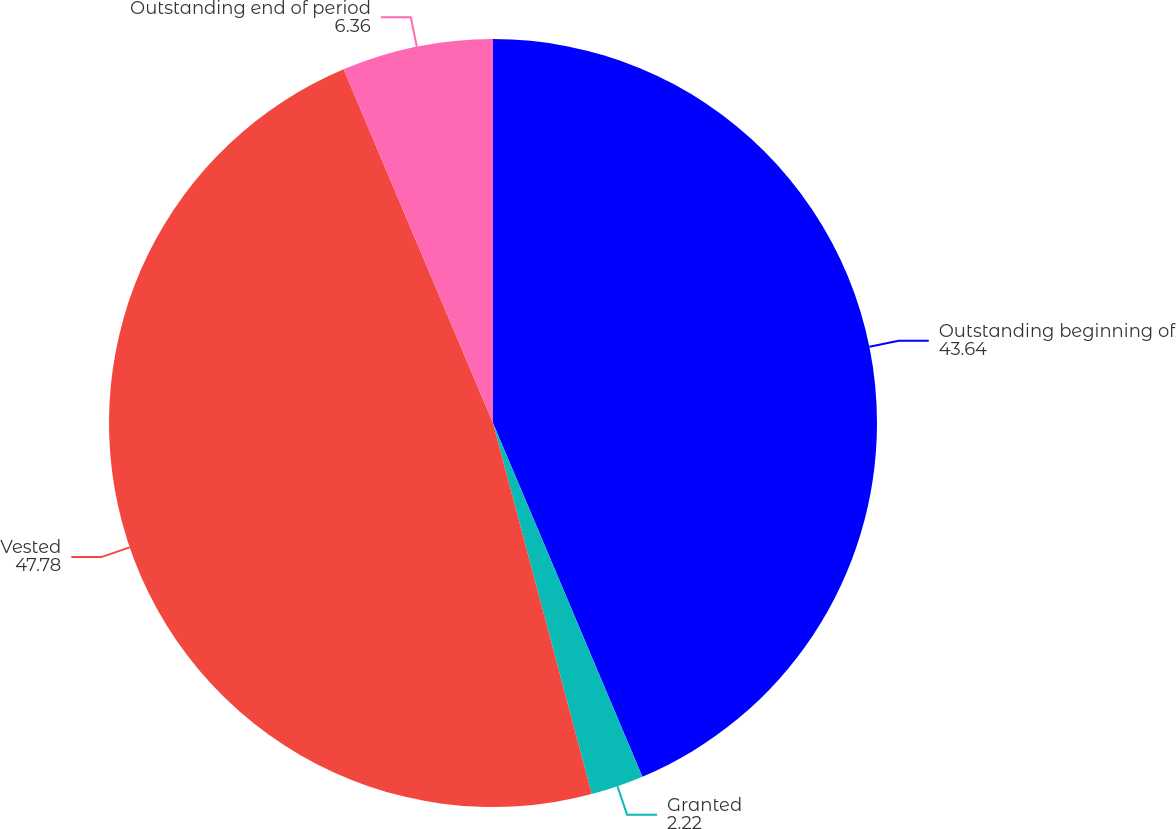<chart> <loc_0><loc_0><loc_500><loc_500><pie_chart><fcel>Outstanding beginning of<fcel>Granted<fcel>Vested<fcel>Outstanding end of period<nl><fcel>43.64%<fcel>2.22%<fcel>47.78%<fcel>6.36%<nl></chart> 